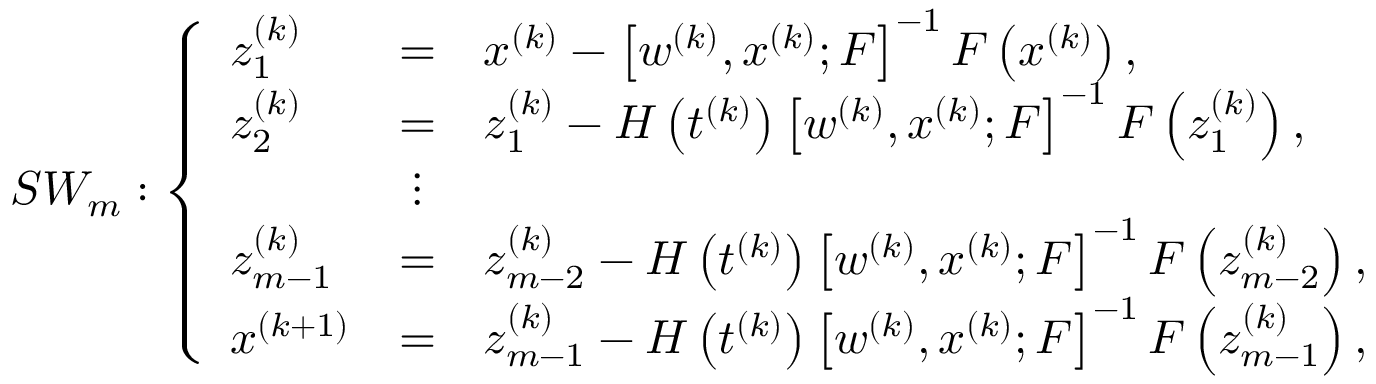<formula> <loc_0><loc_0><loc_500><loc_500>S W _ { m } \colon \left \{ \begin{array} { l c l } { z _ { 1 } ^ { ( k ) } } & { = } & { x ^ { ( k ) } - \left [ w ^ { ( k ) } , x ^ { ( k ) } ; F \right ] ^ { - 1 } F \left ( x ^ { ( k ) } \right ) , } \\ { z _ { 2 } ^ { ( k ) } } & { = } & { z _ { 1 } ^ { ( k ) } - H \left ( t ^ { ( k ) } \right ) \left [ w ^ { ( k ) } , x ^ { ( k ) } ; F \right ] ^ { - 1 } F \left ( z _ { 1 } ^ { ( k ) } \right ) , } \\ & { \vdots } & \\ { z _ { m - 1 } ^ { ( k ) } } & { = } & { z _ { m - 2 } ^ { ( k ) } - H \left ( t ^ { ( k ) } \right ) \left [ w ^ { ( k ) } , x ^ { ( k ) } ; F \right ] ^ { - 1 } F \left ( z _ { m - 2 } ^ { ( k ) } \right ) , } \\ { x ^ { ( k + 1 ) } } & { = } & { z _ { m - 1 } ^ { ( k ) } - H \left ( t ^ { ( k ) } \right ) \left [ w ^ { ( k ) } , x ^ { ( k ) } ; F \right ] ^ { - 1 } F \left ( z _ { m - 1 } ^ { ( k ) } \right ) , } \end{array}</formula> 